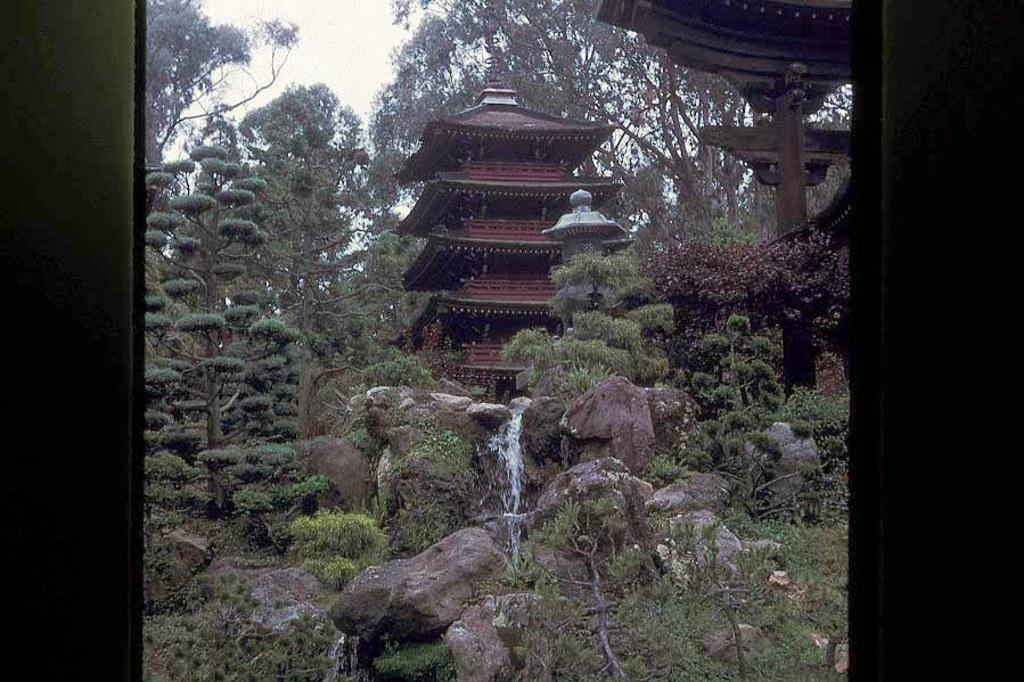What type of structures can be seen in the image? There are buildings in the image. What type of natural elements are present in the image? There are trees and rocks in the image. What is the water feature in the image? There is water visible in the image. How many centimeters of wax can be seen on the buildings in the image? There is no wax present on the buildings in the image. Can you tell me how many swimmers are in the water in the image? There are no swimmers visible in the image; it only shows water. 